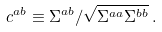Convert formula to latex. <formula><loc_0><loc_0><loc_500><loc_500>c ^ { a b } \equiv \Sigma ^ { a b } / \sqrt { \Sigma ^ { a a } \Sigma ^ { b b } } \, .</formula> 